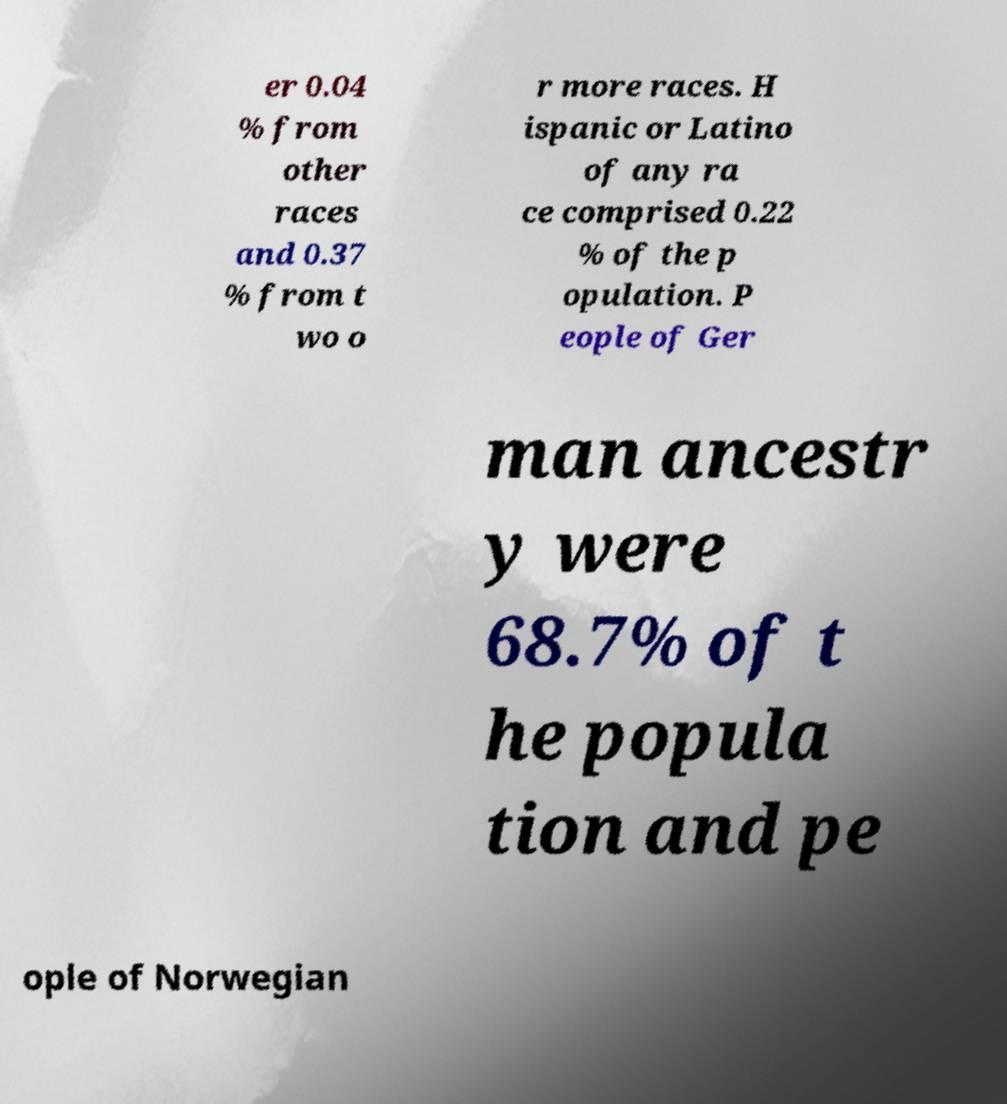Could you assist in decoding the text presented in this image and type it out clearly? er 0.04 % from other races and 0.37 % from t wo o r more races. H ispanic or Latino of any ra ce comprised 0.22 % of the p opulation. P eople of Ger man ancestr y were 68.7% of t he popula tion and pe ople of Norwegian 